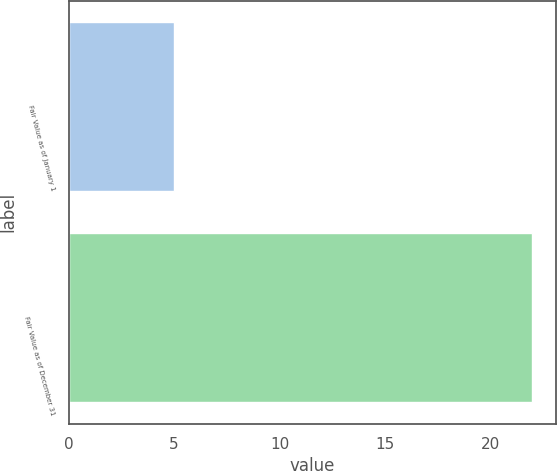Convert chart to OTSL. <chart><loc_0><loc_0><loc_500><loc_500><bar_chart><fcel>Fair Value as of January 1<fcel>Fair Value as of December 31<nl><fcel>5<fcel>22<nl></chart> 